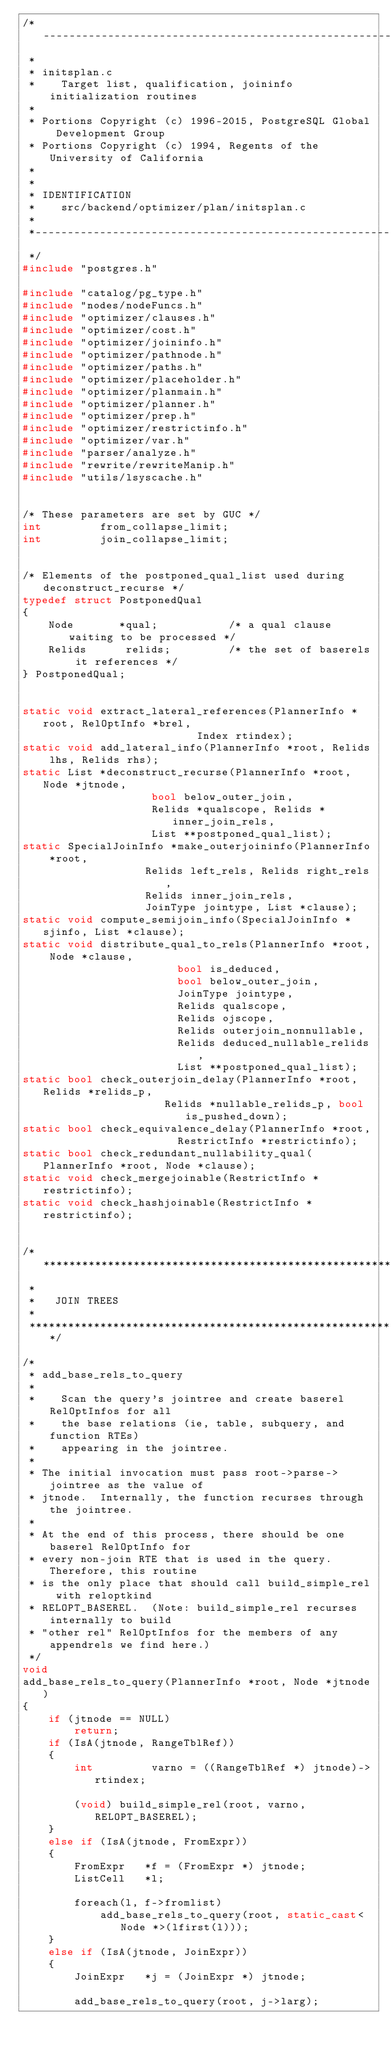Convert code to text. <code><loc_0><loc_0><loc_500><loc_500><_C++_>/*-------------------------------------------------------------------------
 *
 * initsplan.c
 *	  Target list, qualification, joininfo initialization routines
 *
 * Portions Copyright (c) 1996-2015, PostgreSQL Global Development Group
 * Portions Copyright (c) 1994, Regents of the University of California
 *
 *
 * IDENTIFICATION
 *	  src/backend/optimizer/plan/initsplan.c
 *
 *-------------------------------------------------------------------------
 */
#include "postgres.h"

#include "catalog/pg_type.h"
#include "nodes/nodeFuncs.h"
#include "optimizer/clauses.h"
#include "optimizer/cost.h"
#include "optimizer/joininfo.h"
#include "optimizer/pathnode.h"
#include "optimizer/paths.h"
#include "optimizer/placeholder.h"
#include "optimizer/planmain.h"
#include "optimizer/planner.h"
#include "optimizer/prep.h"
#include "optimizer/restrictinfo.h"
#include "optimizer/var.h"
#include "parser/analyze.h"
#include "rewrite/rewriteManip.h"
#include "utils/lsyscache.h"


/* These parameters are set by GUC */
int			from_collapse_limit;
int			join_collapse_limit;


/* Elements of the postponed_qual_list used during deconstruct_recurse */
typedef struct PostponedQual
{
	Node	   *qual;			/* a qual clause waiting to be processed */
	Relids		relids;			/* the set of baserels it references */
} PostponedQual;


static void extract_lateral_references(PlannerInfo *root, RelOptInfo *brel,
						   Index rtindex);
static void add_lateral_info(PlannerInfo *root, Relids lhs, Relids rhs);
static List *deconstruct_recurse(PlannerInfo *root, Node *jtnode,
					bool below_outer_join,
					Relids *qualscope, Relids *inner_join_rels,
					List **postponed_qual_list);
static SpecialJoinInfo *make_outerjoininfo(PlannerInfo *root,
				   Relids left_rels, Relids right_rels,
				   Relids inner_join_rels,
				   JoinType jointype, List *clause);
static void compute_semijoin_info(SpecialJoinInfo *sjinfo, List *clause);
static void distribute_qual_to_rels(PlannerInfo *root, Node *clause,
						bool is_deduced,
						bool below_outer_join,
						JoinType jointype,
						Relids qualscope,
						Relids ojscope,
						Relids outerjoin_nonnullable,
						Relids deduced_nullable_relids,
						List **postponed_qual_list);
static bool check_outerjoin_delay(PlannerInfo *root, Relids *relids_p,
					  Relids *nullable_relids_p, bool is_pushed_down);
static bool check_equivalence_delay(PlannerInfo *root,
						RestrictInfo *restrictinfo);
static bool check_redundant_nullability_qual(PlannerInfo *root, Node *clause);
static void check_mergejoinable(RestrictInfo *restrictinfo);
static void check_hashjoinable(RestrictInfo *restrictinfo);


/*****************************************************************************
 *
 *	 JOIN TREES
 *
 *****************************************************************************/

/*
 * add_base_rels_to_query
 *
 *	  Scan the query's jointree and create baserel RelOptInfos for all
 *	  the base relations (ie, table, subquery, and function RTEs)
 *	  appearing in the jointree.
 *
 * The initial invocation must pass root->parse->jointree as the value of
 * jtnode.  Internally, the function recurses through the jointree.
 *
 * At the end of this process, there should be one baserel RelOptInfo for
 * every non-join RTE that is used in the query.  Therefore, this routine
 * is the only place that should call build_simple_rel with reloptkind
 * RELOPT_BASEREL.  (Note: build_simple_rel recurses internally to build
 * "other rel" RelOptInfos for the members of any appendrels we find here.)
 */
void
add_base_rels_to_query(PlannerInfo *root, Node *jtnode)
{
	if (jtnode == NULL)
		return;
	if (IsA(jtnode, RangeTblRef))
	{
		int			varno = ((RangeTblRef *) jtnode)->rtindex;

		(void) build_simple_rel(root, varno, RELOPT_BASEREL);
	}
	else if (IsA(jtnode, FromExpr))
	{
		FromExpr   *f = (FromExpr *) jtnode;
		ListCell   *l;

		foreach(l, f->fromlist)
			add_base_rels_to_query(root, static_cast<Node *>(lfirst(l)));
	}
	else if (IsA(jtnode, JoinExpr))
	{
		JoinExpr   *j = (JoinExpr *) jtnode;

		add_base_rels_to_query(root, j->larg);</code> 